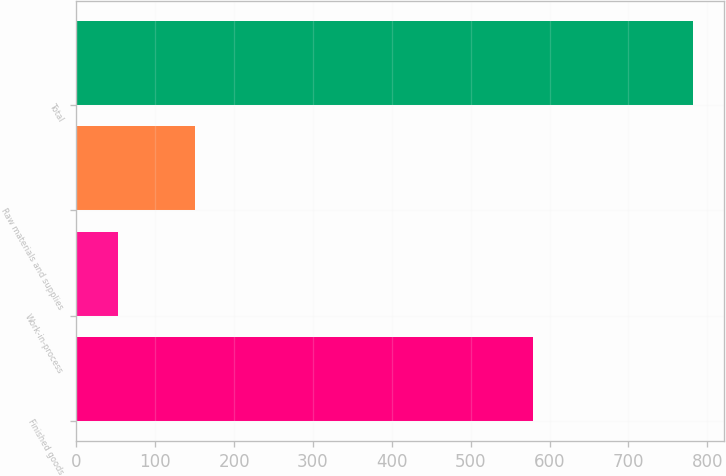Convert chart. <chart><loc_0><loc_0><loc_500><loc_500><bar_chart><fcel>Finished goods<fcel>Work-in-process<fcel>Raw materials and supplies<fcel>Total<nl><fcel>579<fcel>53<fcel>150<fcel>782<nl></chart> 